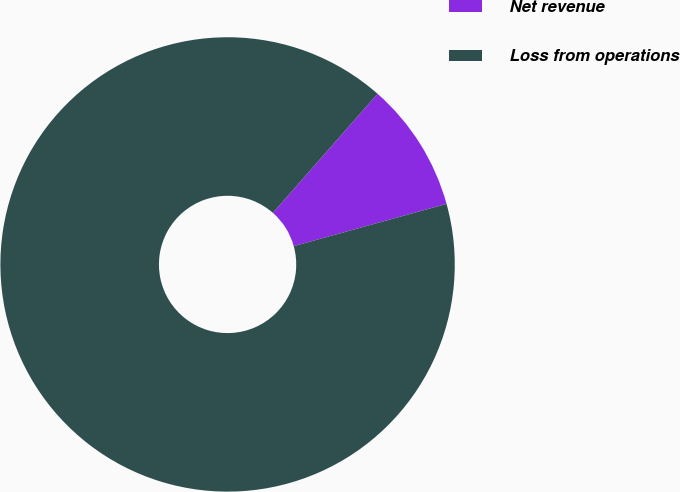Convert chart. <chart><loc_0><loc_0><loc_500><loc_500><pie_chart><fcel>Net revenue<fcel>Loss from operations<nl><fcel>9.23%<fcel>90.77%<nl></chart> 